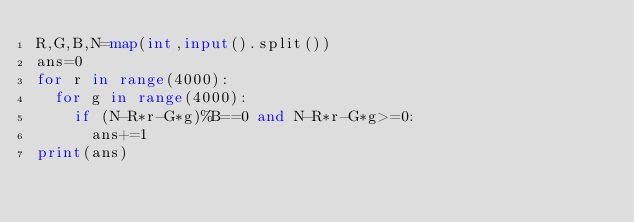Convert code to text. <code><loc_0><loc_0><loc_500><loc_500><_Python_>R,G,B,N=map(int,input().split())
ans=0
for r in range(4000):
  for g in range(4000):
    if (N-R*r-G*g)%B==0 and N-R*r-G*g>=0:
      ans+=1
print(ans)</code> 